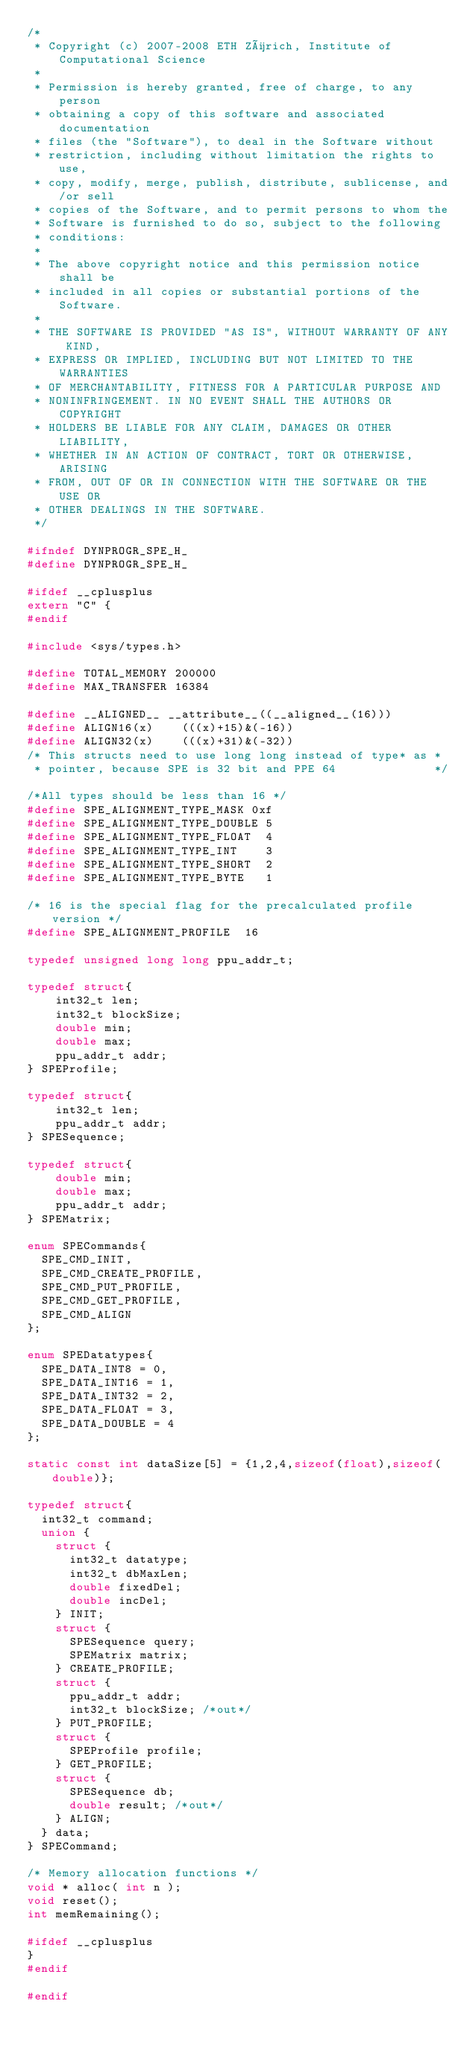<code> <loc_0><loc_0><loc_500><loc_500><_C_>/*
 * Copyright (c) 2007-2008 ETH Zürich, Institute of Computational Science
 *
 * Permission is hereby granted, free of charge, to any person
 * obtaining a copy of this software and associated documentation
 * files (the "Software"), to deal in the Software without
 * restriction, including without limitation the rights to use,
 * copy, modify, merge, publish, distribute, sublicense, and/or sell
 * copies of the Software, and to permit persons to whom the
 * Software is furnished to do so, subject to the following
 * conditions:
 *
 * The above copyright notice and this permission notice shall be
 * included in all copies or substantial portions of the Software.
 *
 * THE SOFTWARE IS PROVIDED "AS IS", WITHOUT WARRANTY OF ANY KIND,
 * EXPRESS OR IMPLIED, INCLUDING BUT NOT LIMITED TO THE WARRANTIES
 * OF MERCHANTABILITY, FITNESS FOR A PARTICULAR PURPOSE AND
 * NONINFRINGEMENT. IN NO EVENT SHALL THE AUTHORS OR COPYRIGHT
 * HOLDERS BE LIABLE FOR ANY CLAIM, DAMAGES OR OTHER LIABILITY,
 * WHETHER IN AN ACTION OF CONTRACT, TORT OR OTHERWISE, ARISING
 * FROM, OUT OF OR IN CONNECTION WITH THE SOFTWARE OR THE USE OR
 * OTHER DEALINGS IN THE SOFTWARE.
 */

#ifndef DYNPROGR_SPE_H_
#define DYNPROGR_SPE_H_

#ifdef __cplusplus
extern "C" {
#endif

#include <sys/types.h>

#define TOTAL_MEMORY 200000
#define MAX_TRANSFER 16384

#define __ALIGNED__ __attribute__((__aligned__(16)))
#define ALIGN16(x)    (((x)+15)&(-16))
#define ALIGN32(x)    (((x)+31)&(-32))
/* This structs need to use long long instead of type* as *
 * pointer, because SPE is 32 bit and PPE 64              */

/*All types should be less than 16 */
#define SPE_ALIGNMENT_TYPE_MASK 0xf
#define SPE_ALIGNMENT_TYPE_DOUBLE 5
#define SPE_ALIGNMENT_TYPE_FLOAT  4
#define SPE_ALIGNMENT_TYPE_INT    3
#define SPE_ALIGNMENT_TYPE_SHORT  2
#define SPE_ALIGNMENT_TYPE_BYTE   1

/* 16 is the special flag for the precalculated profile version */
#define SPE_ALIGNMENT_PROFILE  16

typedef unsigned long long ppu_addr_t;

typedef struct{
    int32_t len;
    int32_t blockSize;
    double min;
    double max;
    ppu_addr_t addr;
} SPEProfile;

typedef struct{
    int32_t len;
    ppu_addr_t addr;
} SPESequence;

typedef struct{
    double min;
    double max;
    ppu_addr_t addr;
} SPEMatrix;

enum SPECommands{
	SPE_CMD_INIT,
	SPE_CMD_CREATE_PROFILE,
	SPE_CMD_PUT_PROFILE,
	SPE_CMD_GET_PROFILE,
	SPE_CMD_ALIGN
};

enum SPEDatatypes{
	SPE_DATA_INT8 = 0,
	SPE_DATA_INT16 = 1,
	SPE_DATA_INT32 = 2,
	SPE_DATA_FLOAT = 3,
	SPE_DATA_DOUBLE = 4
};

static const int dataSize[5] = {1,2,4,sizeof(float),sizeof(double)};

typedef struct{
	int32_t command;
	union {
		struct {
			int32_t datatype;
			int32_t dbMaxLen;
			double fixedDel;
			double incDel;
		} INIT;
		struct {
			SPESequence query;
			SPEMatrix matrix;
		} CREATE_PROFILE;
		struct {
			ppu_addr_t addr;
			int32_t blockSize; /*out*/
		} PUT_PROFILE;
		struct {
			SPEProfile profile;
		} GET_PROFILE;
		struct {
			SPESequence db;
			double result; /*out*/
		} ALIGN;
	} data;
} SPECommand;

/* Memory allocation functions */
void * alloc( int n );
void reset();
int memRemaining();

#ifdef __cplusplus
}
#endif

#endif
</code> 